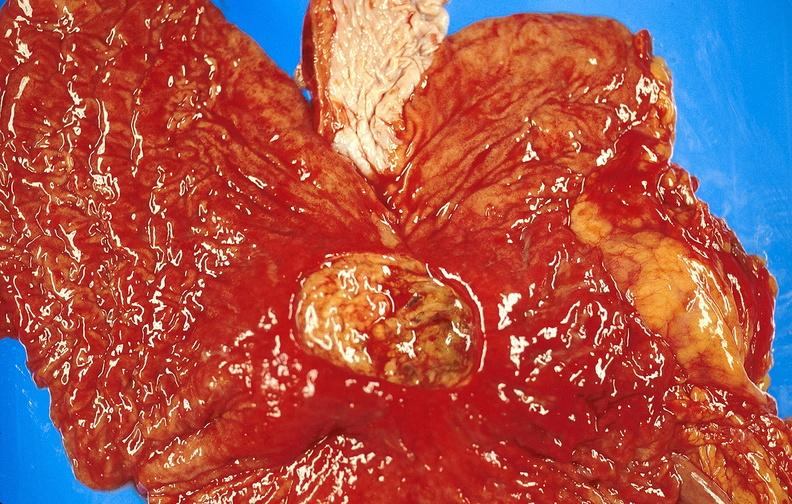does this image show gastric ulcer?
Answer the question using a single word or phrase. Yes 